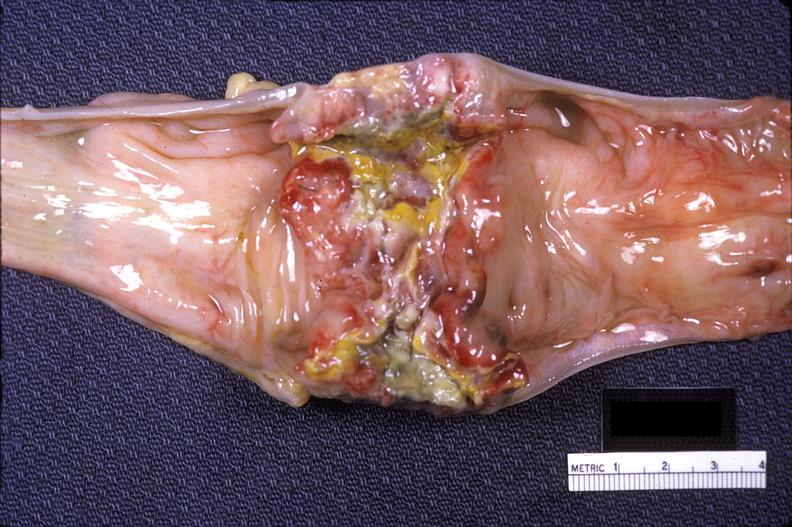what does this image show?
Answer the question using a single word or phrase. Colon sigmoid 